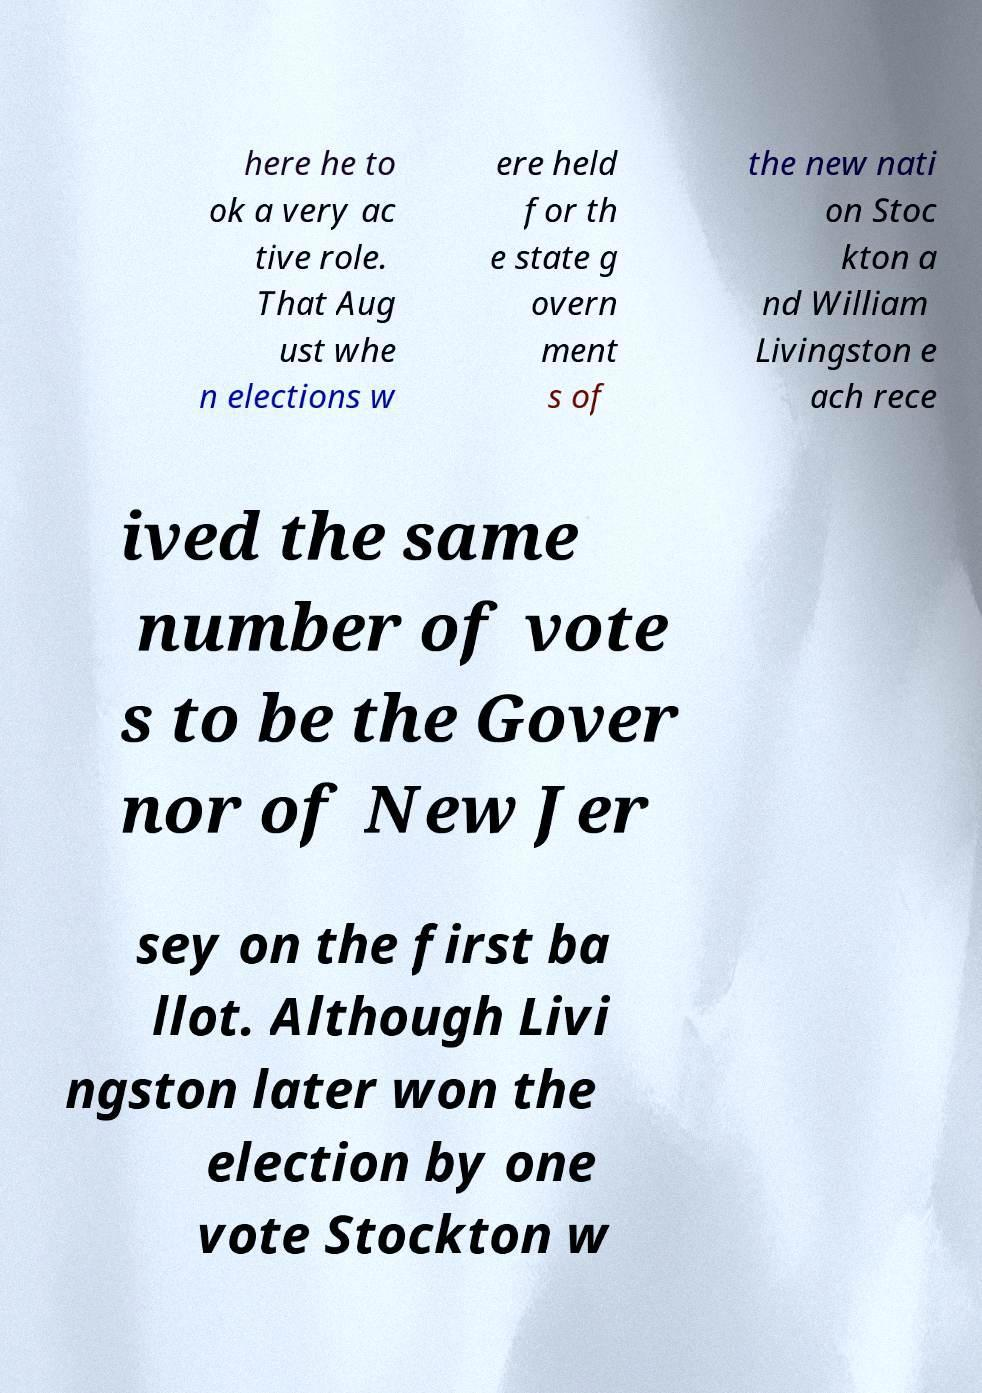For documentation purposes, I need the text within this image transcribed. Could you provide that? here he to ok a very ac tive role. That Aug ust whe n elections w ere held for th e state g overn ment s of the new nati on Stoc kton a nd William Livingston e ach rece ived the same number of vote s to be the Gover nor of New Jer sey on the first ba llot. Although Livi ngston later won the election by one vote Stockton w 